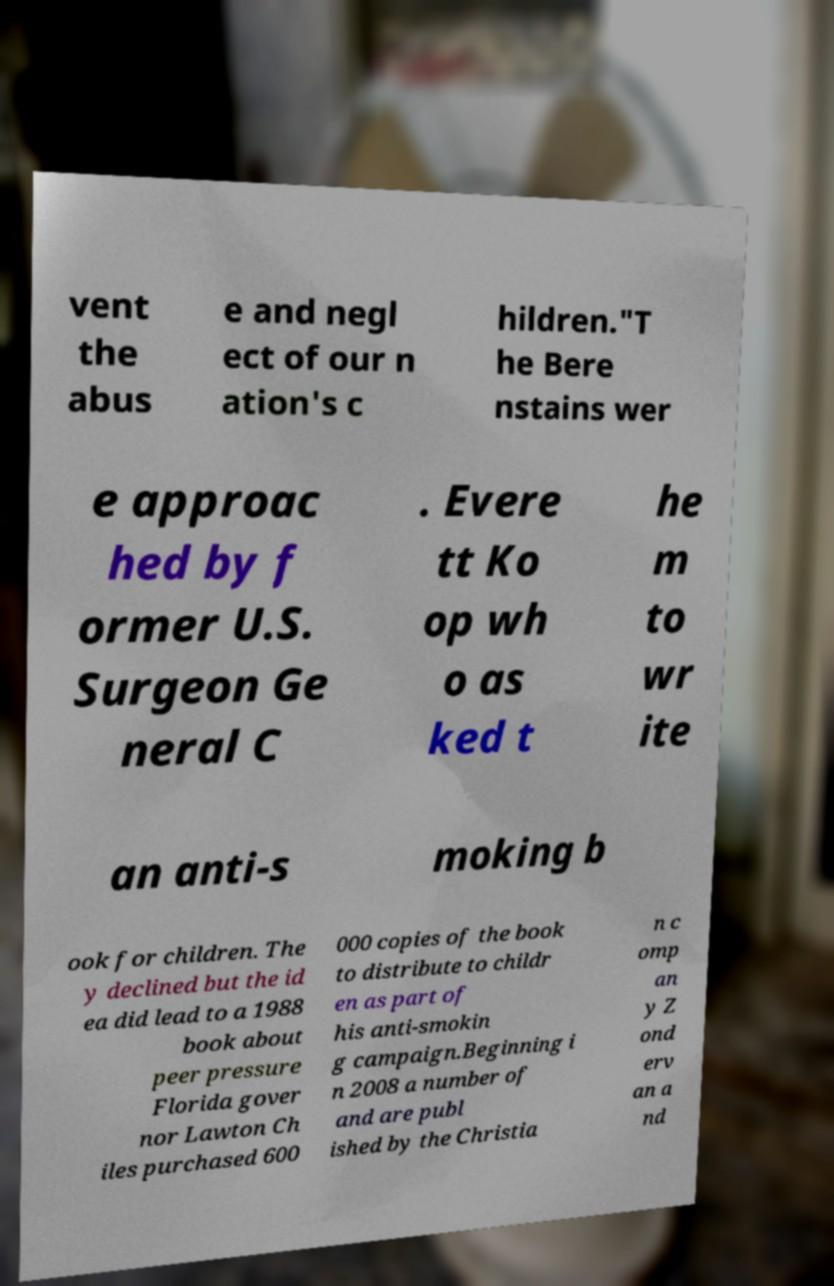There's text embedded in this image that I need extracted. Can you transcribe it verbatim? vent the abus e and negl ect of our n ation's c hildren."T he Bere nstains wer e approac hed by f ormer U.S. Surgeon Ge neral C . Evere tt Ko op wh o as ked t he m to wr ite an anti-s moking b ook for children. The y declined but the id ea did lead to a 1988 book about peer pressure Florida gover nor Lawton Ch iles purchased 600 000 copies of the book to distribute to childr en as part of his anti-smokin g campaign.Beginning i n 2008 a number of and are publ ished by the Christia n c omp an y Z ond erv an a nd 